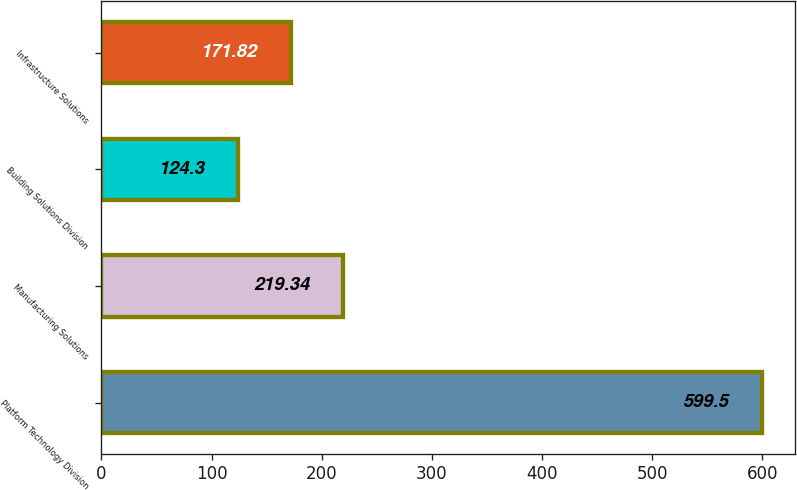<chart> <loc_0><loc_0><loc_500><loc_500><bar_chart><fcel>Platform Technology Division<fcel>Manufacturing Solutions<fcel>Building Solutions Division<fcel>Infrastructure Solutions<nl><fcel>599.5<fcel>219.34<fcel>124.3<fcel>171.82<nl></chart> 